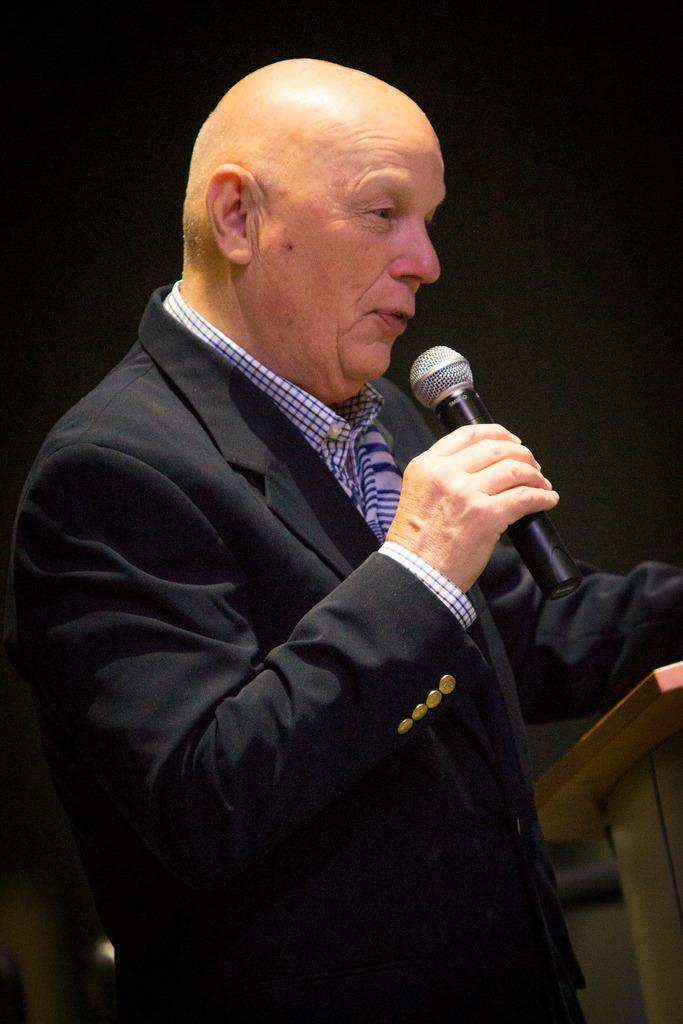In one or two sentences, can you explain what this image depicts? In this image there is a man standing near the podium by holding a mic in his hand. 